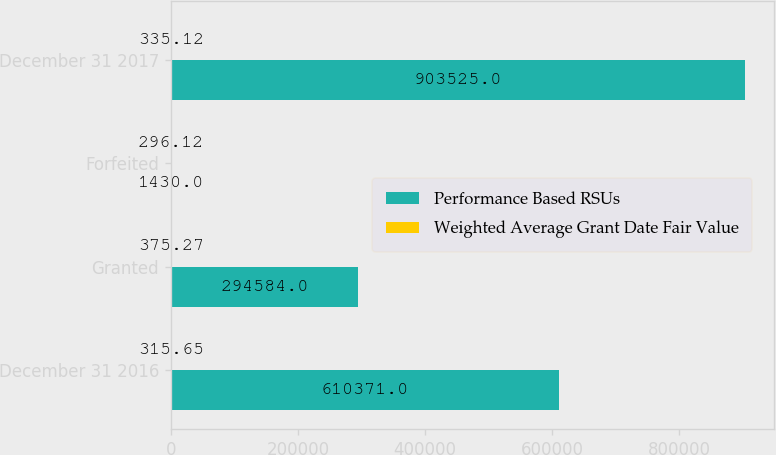Convert chart. <chart><loc_0><loc_0><loc_500><loc_500><stacked_bar_chart><ecel><fcel>December 31 2016<fcel>Granted<fcel>Forfeited<fcel>December 31 2017<nl><fcel>Performance Based RSUs<fcel>610371<fcel>294584<fcel>1430<fcel>903525<nl><fcel>Weighted Average Grant Date Fair Value<fcel>315.65<fcel>375.27<fcel>296.12<fcel>335.12<nl></chart> 